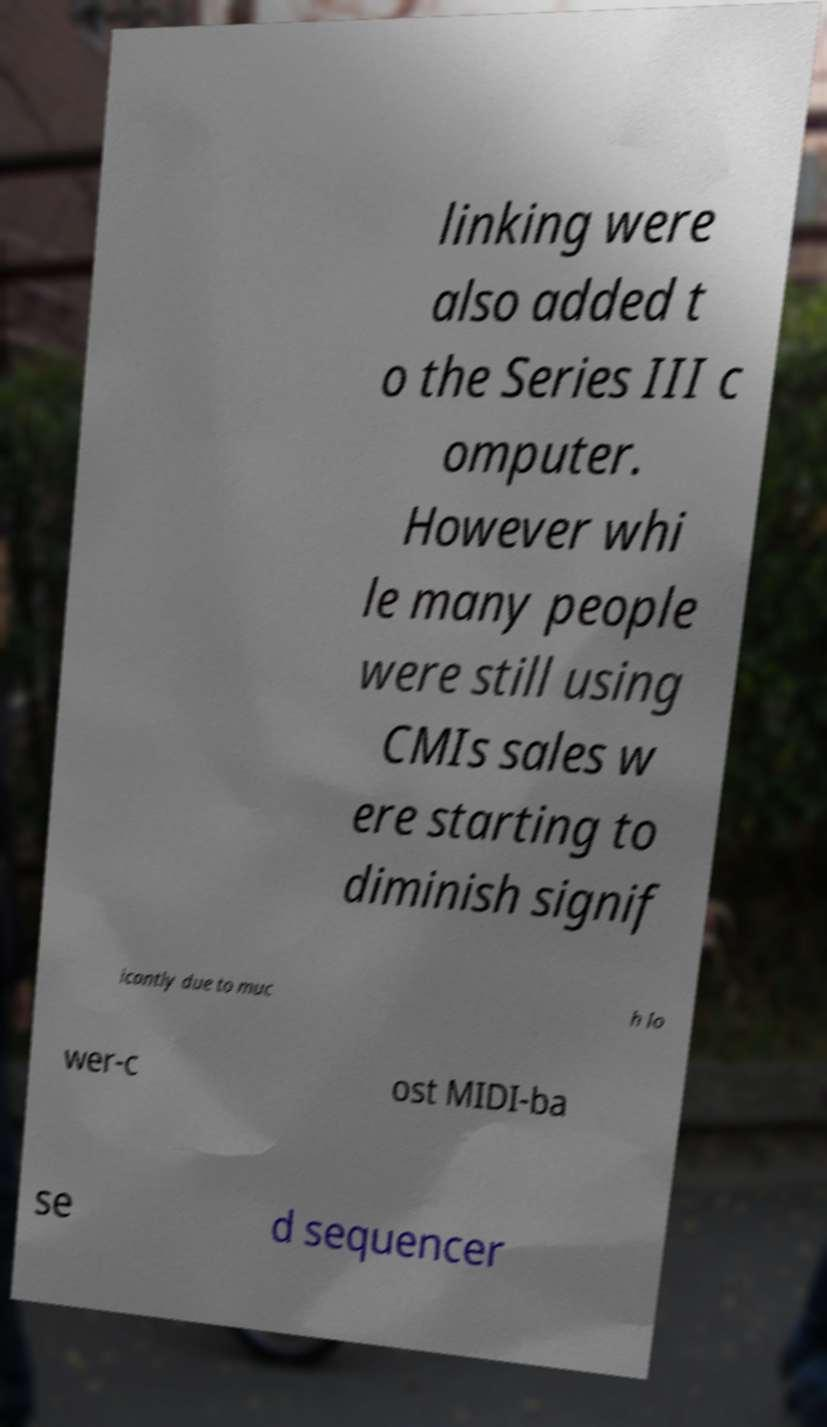Could you assist in decoding the text presented in this image and type it out clearly? linking were also added t o the Series III c omputer. However whi le many people were still using CMIs sales w ere starting to diminish signif icantly due to muc h lo wer-c ost MIDI-ba se d sequencer 